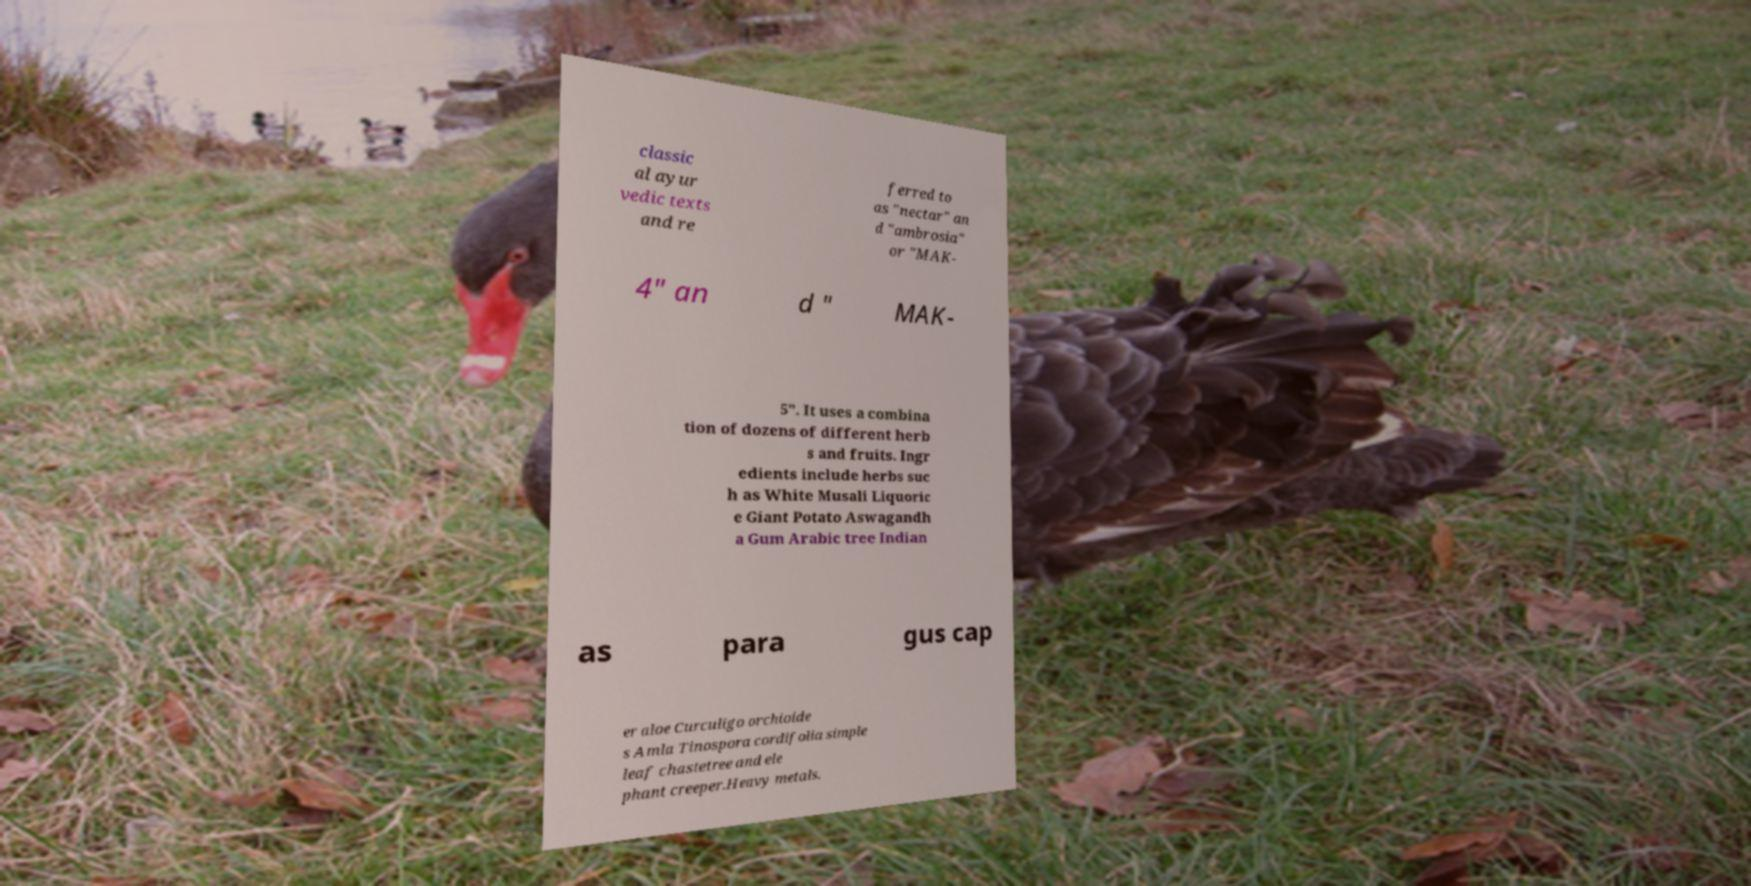I need the written content from this picture converted into text. Can you do that? classic al ayur vedic texts and re ferred to as "nectar" an d "ambrosia" or "MAK- 4" an d " MAK- 5". It uses a combina tion of dozens of different herb s and fruits. Ingr edients include herbs suc h as White Musali Liquoric e Giant Potato Aswagandh a Gum Arabic tree Indian as para gus cap er aloe Curculigo orchioide s Amla Tinospora cordifolia simple leaf chastetree and ele phant creeper.Heavy metals. 